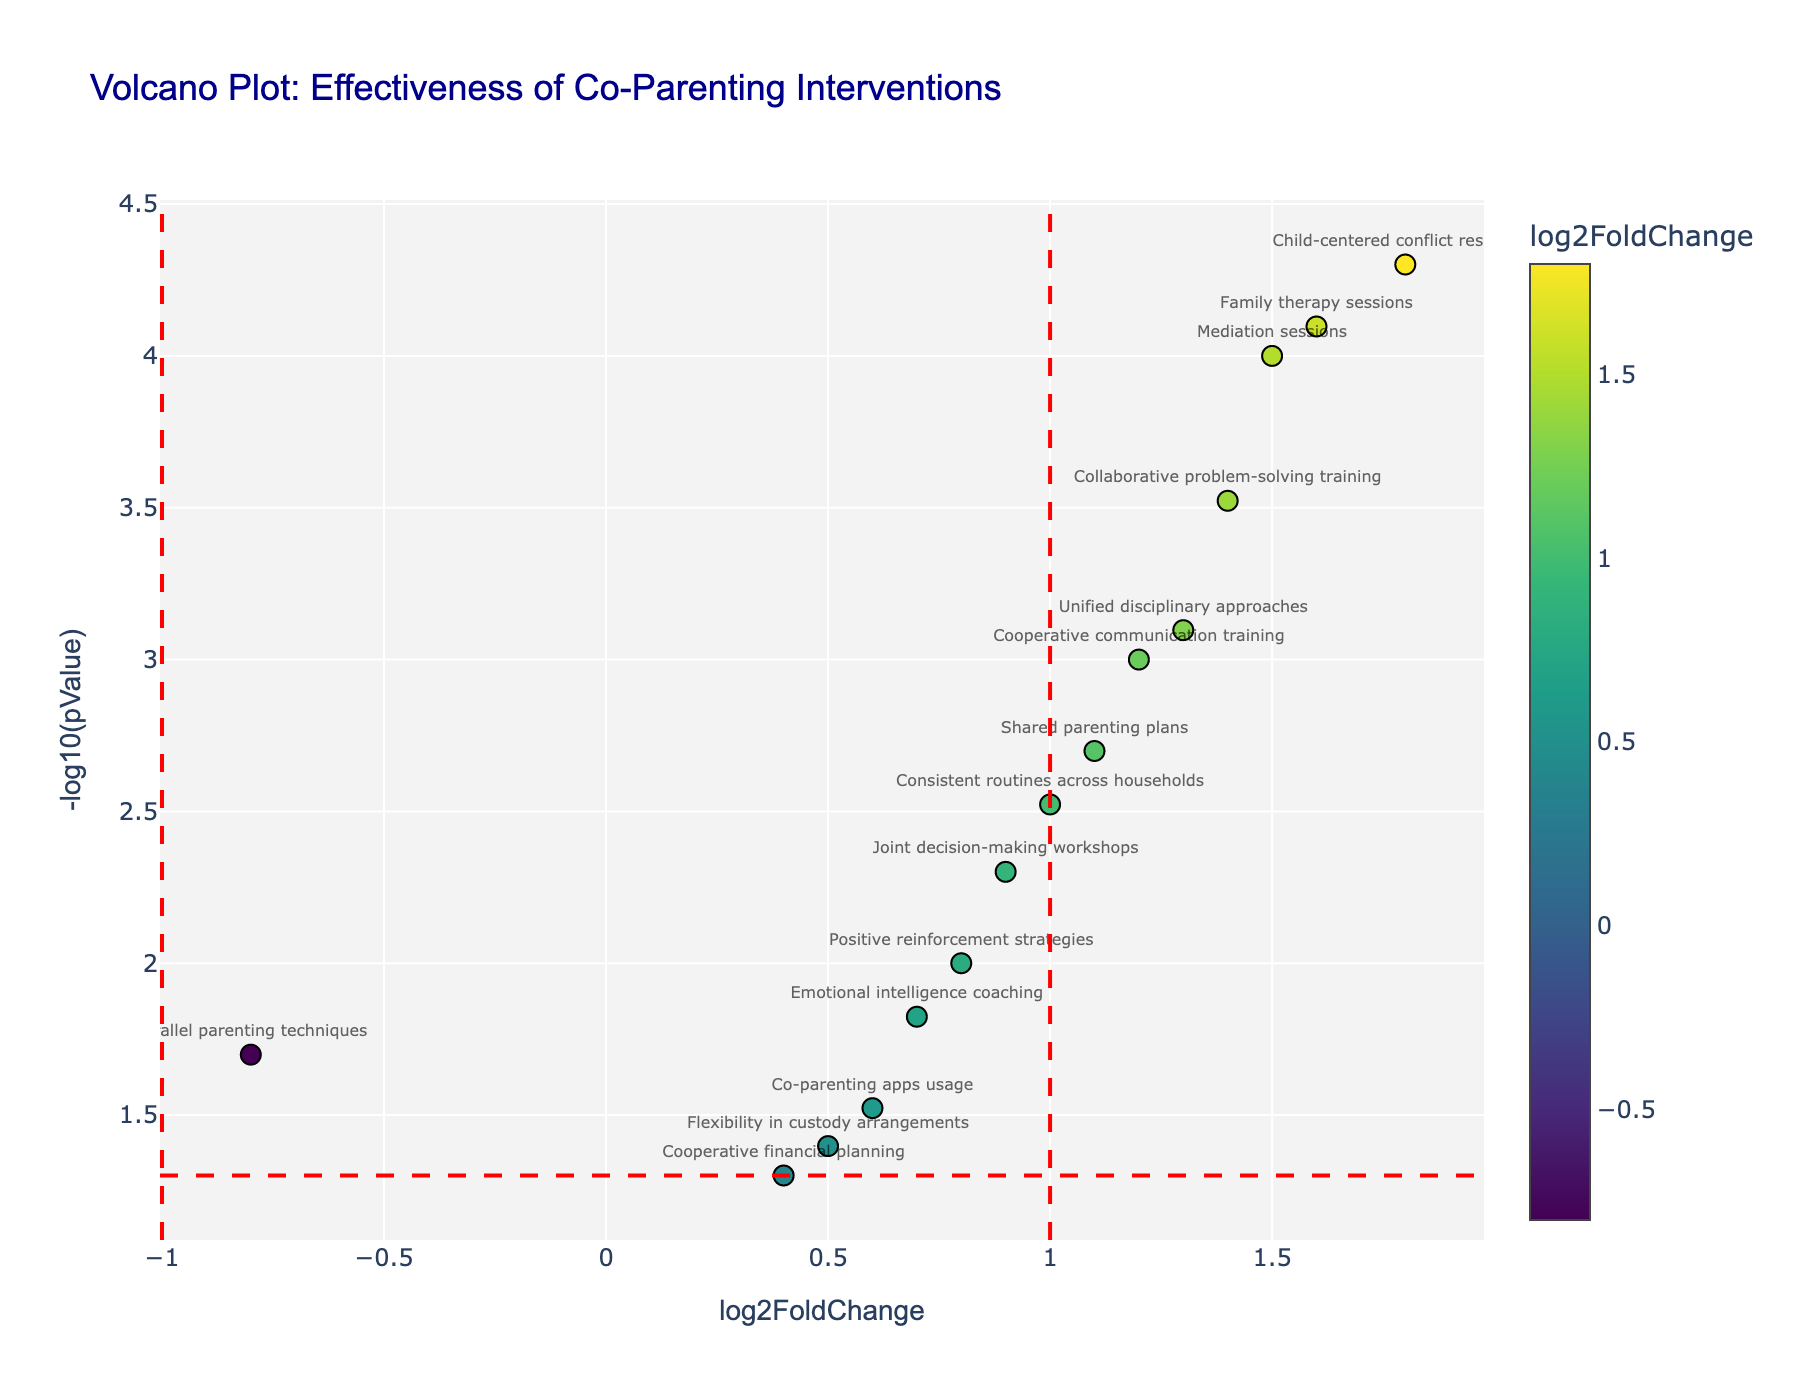What is the title of the plot? The title is typically displayed at the top center of the plot. In this case, it reads "Volcano Plot: Effectiveness of Co-Parenting Interventions".
Answer: "Volcano Plot: Effectiveness of Co-Parenting Interventions" Which intervention has the highest effectiveness according to the plot? To find the intervention with the highest effectiveness, look for the point with the highest log2(FC) on the x-axis. The intervention "Child-centered conflict resolution" has the highest log2FoldChange value of 1.8.
Answer: Child-centered conflict resolution What does the y-axis represent? The y-axis represents the -log10(pValue), which indicates the statistical significance of the intervention's effect. Higher values on the y-axis indicate more statistically significant results.
Answer: -log10(pValue) How many interventions have a log2FoldChange greater than 1 and a p-value below 0.05? To answer this, find points located to the right of the vertical line at x = 1 and above the horizontal line at y = -log10(0.05). There are 5 such points: "Mediation sessions", "Shared parenting plans", "Family therapy sessions", "Collaborative problem-solving training", and "Unified disciplinary approaches".
Answer: 5 Which intervention has the least impact, and what is its log2FoldChange value? The intervention with the least impact will have the lowest log2FoldChange value. "Parallel parenting techniques" has the least impact with a log2FoldChange value of -0.8.
Answer: Parallel parenting techniques, -0.8 Which interventions are above the significance threshold of p < 0.05? To determine this, look for all points above the horizontal line at y = -log10(0.05). There are 11 interventions meeting this criterion. The threshold line helps to identify significant data points visually.
Answer: 11 Are there more interventions with positive or negative log2FoldChange values? Count the points to the right (positive values) and left (negative values) of x = 0. There are 12 points with positive values and 3 with negative values. Therefore, there are more interventions with positive log2FoldChange values.
Answer: Positive Which intervention has the second highest statistical significance, and what is its -log10(pValue) value? To determine this, look for the point that's second highest on the y-axis. "Family therapy sessions" has the second highest -log10(pValue) value of around 4.1.
Answer: Family therapy sessions, 4.1 How many interventions are included in the plot? The total number of interventions can be determined by counting all the data points in the plot. There are 15 interventions in total.
Answer: 15 What does the red dashed horizontal line represent? The red dashed horizontal line represents the threshold for statistical significance, which is at p = 0.05. In terms of y-axis values, it corresponds to -log10(0.05) ≈ 1.3.
Answer: Statistical significance threshold (p = 0.05) 